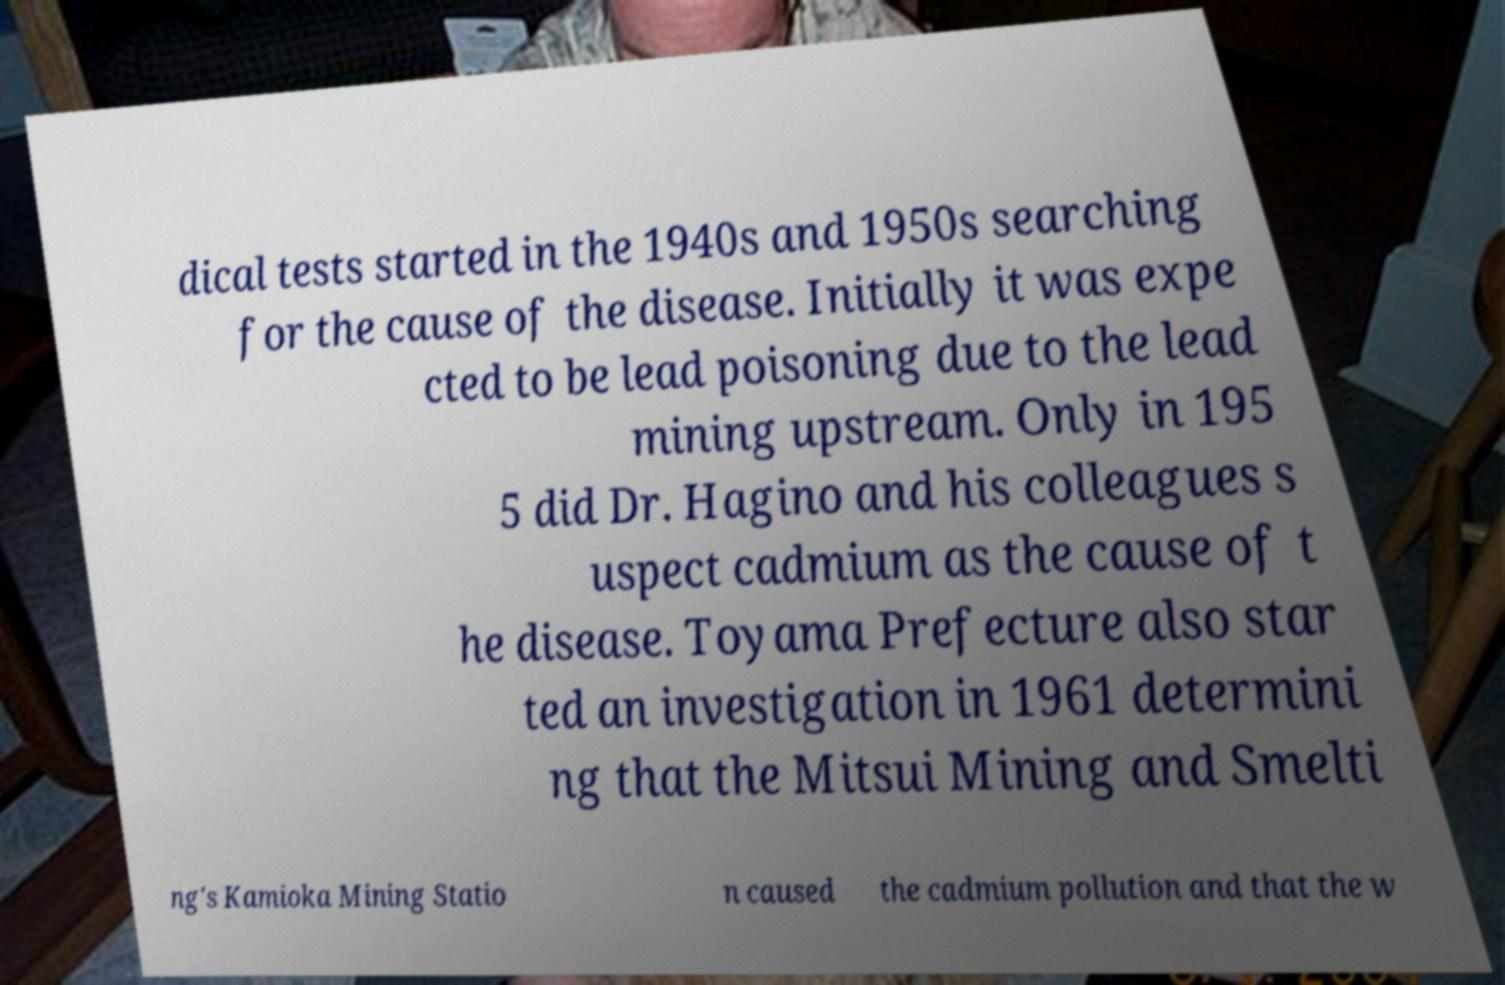There's text embedded in this image that I need extracted. Can you transcribe it verbatim? dical tests started in the 1940s and 1950s searching for the cause of the disease. Initially it was expe cted to be lead poisoning due to the lead mining upstream. Only in 195 5 did Dr. Hagino and his colleagues s uspect cadmium as the cause of t he disease. Toyama Prefecture also star ted an investigation in 1961 determini ng that the Mitsui Mining and Smelti ng's Kamioka Mining Statio n caused the cadmium pollution and that the w 